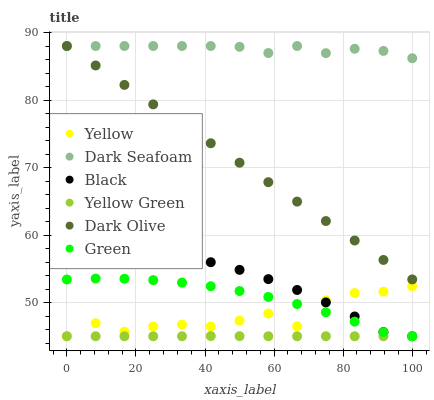Does Yellow Green have the minimum area under the curve?
Answer yes or no. Yes. Does Dark Seafoam have the maximum area under the curve?
Answer yes or no. Yes. Does Dark Olive have the minimum area under the curve?
Answer yes or no. No. Does Dark Olive have the maximum area under the curve?
Answer yes or no. No. Is Dark Olive the smoothest?
Answer yes or no. Yes. Is Yellow the roughest?
Answer yes or no. Yes. Is Yellow the smoothest?
Answer yes or no. No. Is Dark Olive the roughest?
Answer yes or no. No. Does Yellow Green have the lowest value?
Answer yes or no. Yes. Does Dark Olive have the lowest value?
Answer yes or no. No. Does Dark Seafoam have the highest value?
Answer yes or no. Yes. Does Yellow have the highest value?
Answer yes or no. No. Is Green less than Dark Seafoam?
Answer yes or no. Yes. Is Dark Olive greater than Yellow?
Answer yes or no. Yes. Does Dark Seafoam intersect Dark Olive?
Answer yes or no. Yes. Is Dark Seafoam less than Dark Olive?
Answer yes or no. No. Is Dark Seafoam greater than Dark Olive?
Answer yes or no. No. Does Green intersect Dark Seafoam?
Answer yes or no. No. 